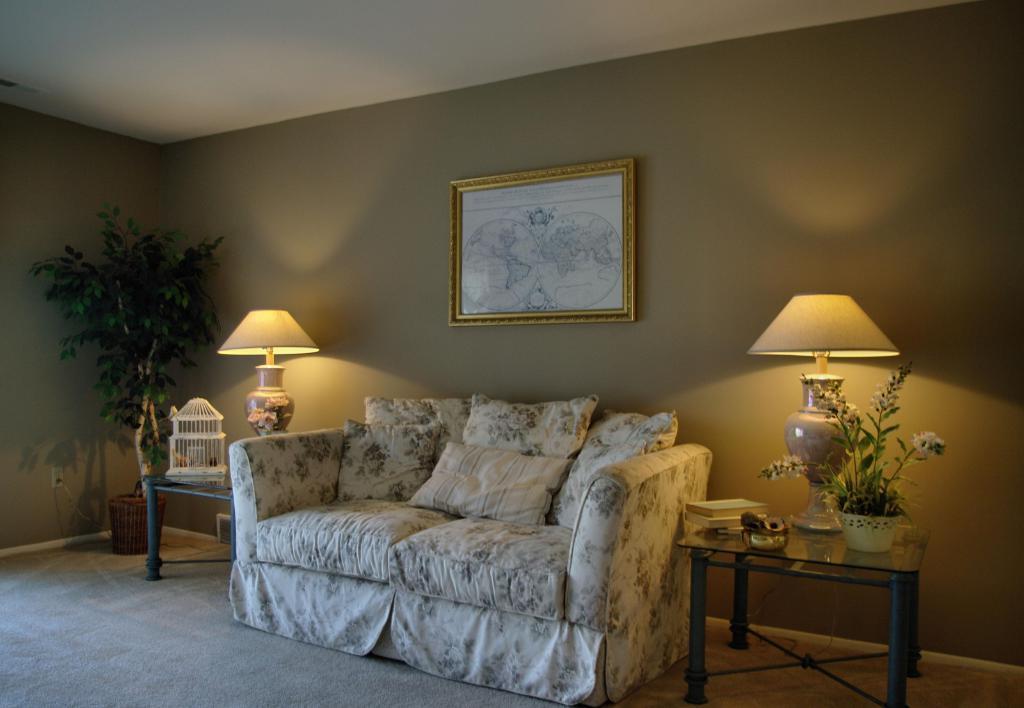In one or two sentences, can you explain what this image depicts? This is a picture of a room where we have a sofa on which there are some pillows and to the right side of the sofa we have a table on which there is a lamp and flowers and to the other side there there is a lamp and a thing and behind the sofa there is a frame to the wall. 